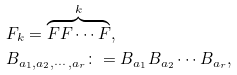Convert formula to latex. <formula><loc_0><loc_0><loc_500><loc_500>& F _ { k } = \overbrace { F F \cdots F } ^ { k } , \\ & B _ { a _ { 1 } , a _ { 2 } , \cdots , a _ { r } } \colon = B _ { a _ { 1 } } B _ { a _ { 2 } } \cdots B _ { a _ { r } } ,</formula> 